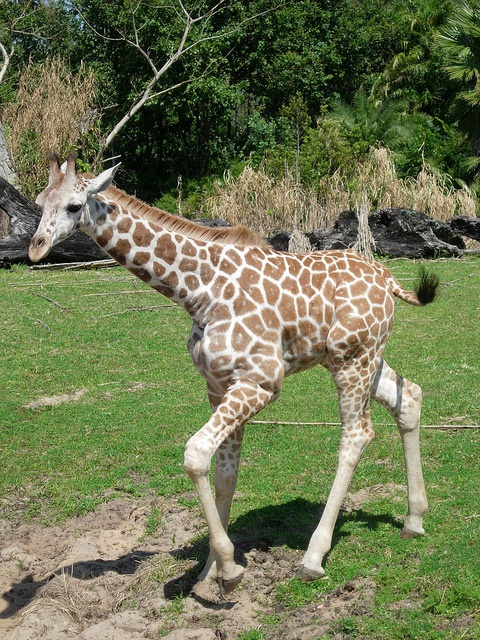Describe the objects in this image and their specific colors. I can see a giraffe in gray, lightgray, tan, and darkgray tones in this image. 